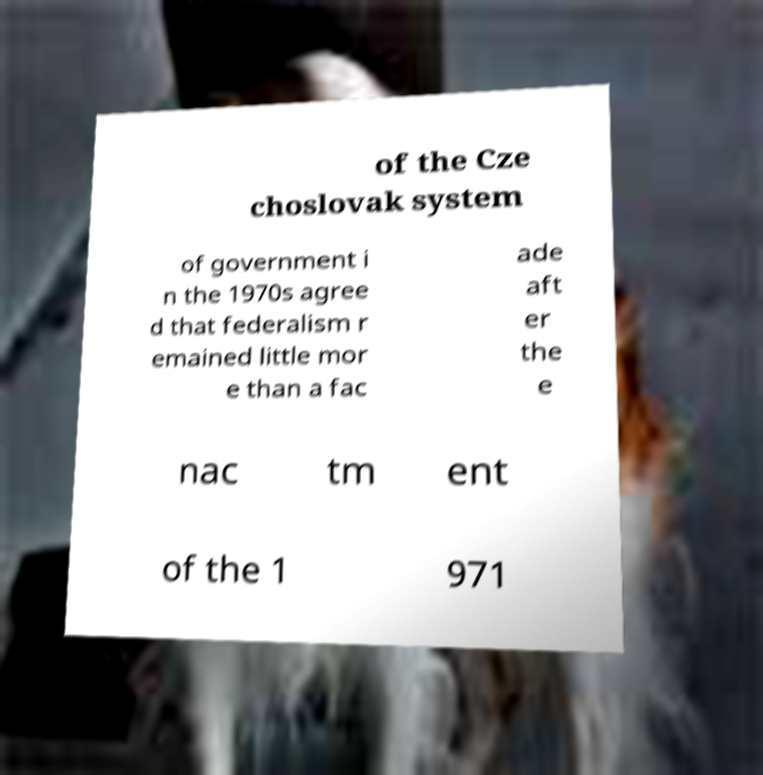Could you extract and type out the text from this image? of the Cze choslovak system of government i n the 1970s agree d that federalism r emained little mor e than a fac ade aft er the e nac tm ent of the 1 971 